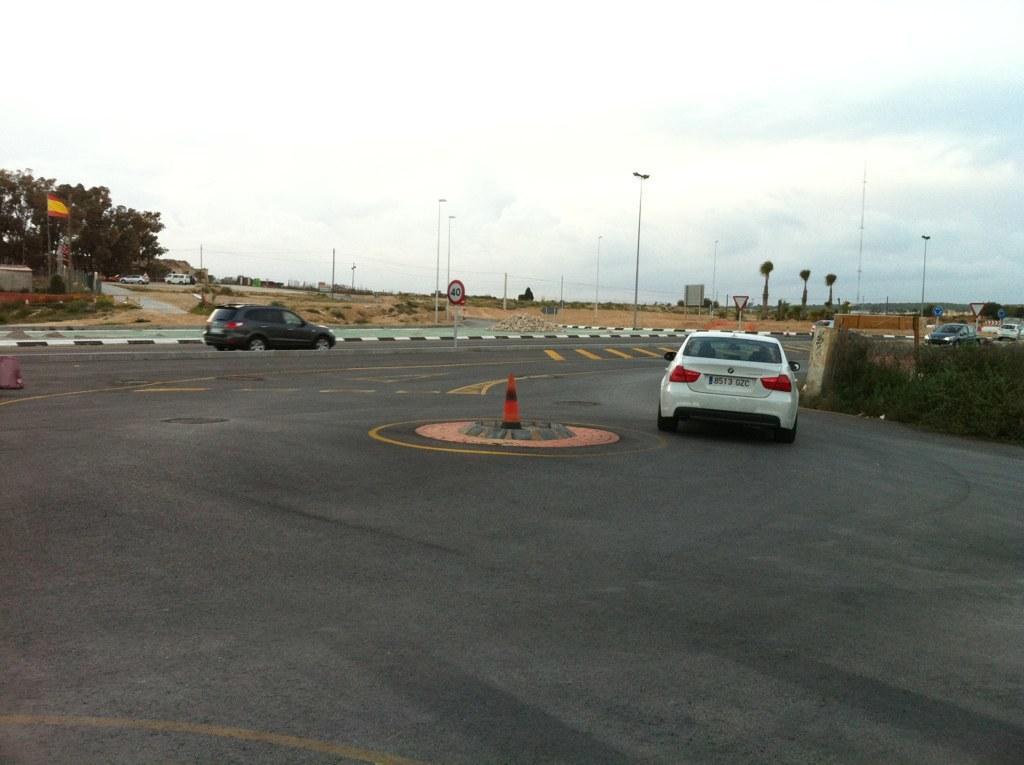How would you summarize this image in a sentence or two? This image is taken outdoors. At the top of the image there is the sky with clouds. At the bottom of the image there is a road. In the background there are few trees and plants. There are many poles. There are two signboards. A few cars are parked on the ground. In the middle of the image two cars are moving on the road and two cars are parked on the road. There is a safety cone. 